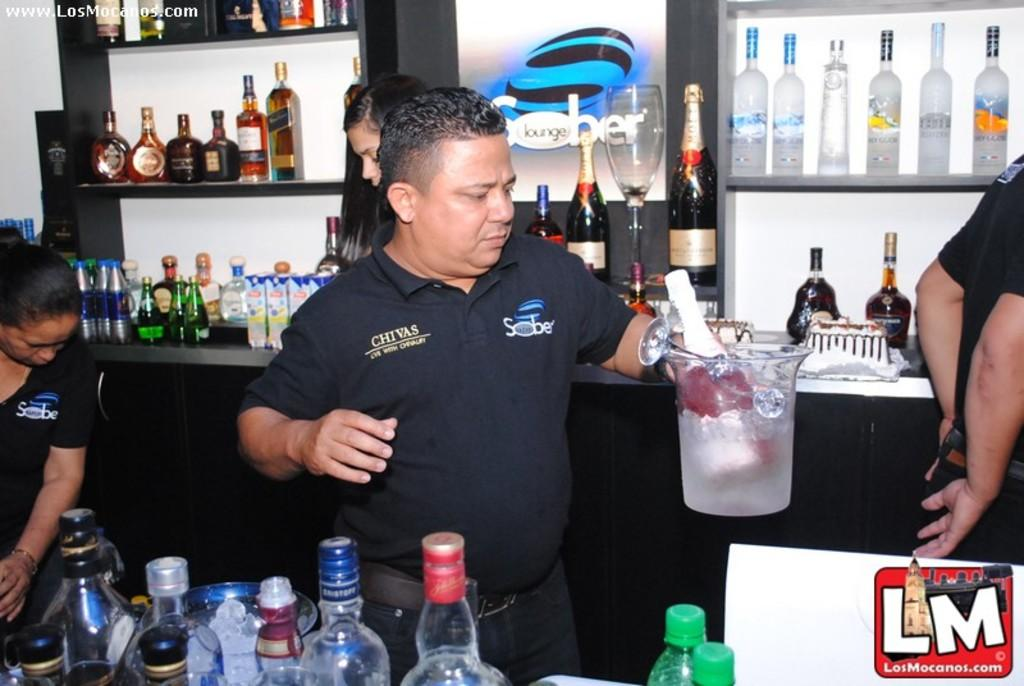How many people are inside the bar counter in the image? There are four people inside the bar counter in the image. What is the man carrying in the image? The man is carrying a jar with ice and a champagne bottle in it. How many rings does the cup on the table have in the image? There is no cup present in the image, so it is not possible to determine the number of rings on a cup. 